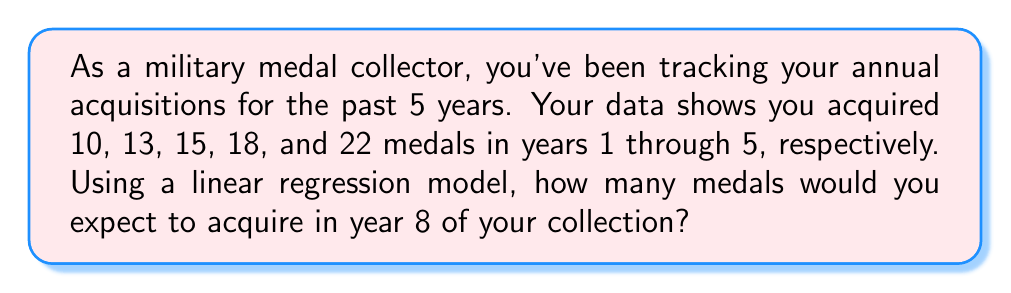Could you help me with this problem? Let's approach this step-by-step using linear regression:

1) First, let's set up our data points:
   x (year): 1, 2, 3, 4, 5
   y (medals): 10, 13, 15, 18, 22

2) We need to find the slope (m) and y-intercept (b) of the line y = mx + b

3) For the slope m, we use the formula:
   $$m = \frac{n\sum xy - \sum x \sum y}{n\sum x^2 - (\sum x)^2}$$

   Where n = 5 (number of data points)
   
   $$\sum x = 1 + 2 + 3 + 4 + 5 = 15$$
   $$\sum y = 10 + 13 + 15 + 18 + 22 = 78$$
   $$\sum xy = 1(10) + 2(13) + 3(15) + 4(18) + 5(22) = 280$$
   $$\sum x^2 = 1^2 + 2^2 + 3^2 + 4^2 + 5^2 = 55$$

4) Plugging these into the slope formula:
   $$m = \frac{5(280) - 15(78)}{5(55) - 15^2} = \frac{1400 - 1170}{275 - 225} = \frac{230}{50} = 4.6$$

5) For the y-intercept b, we use the formula:
   $$b = \frac{\sum y - m\sum x}{n}$$

   $$b = \frac{78 - 4.6(15)}{5} = \frac{78 - 69}{5} = 1.8$$

6) So our linear regression equation is:
   $$y = 4.6x + 1.8$$

7) To predict the number of medals for year 8, we substitute x = 8:
   $$y = 4.6(8) + 1.8 = 36.8 + 1.8 = 38.6$$

8) Since we can't acquire a fractional medal, we round to the nearest whole number: 39
Answer: 39 medals 